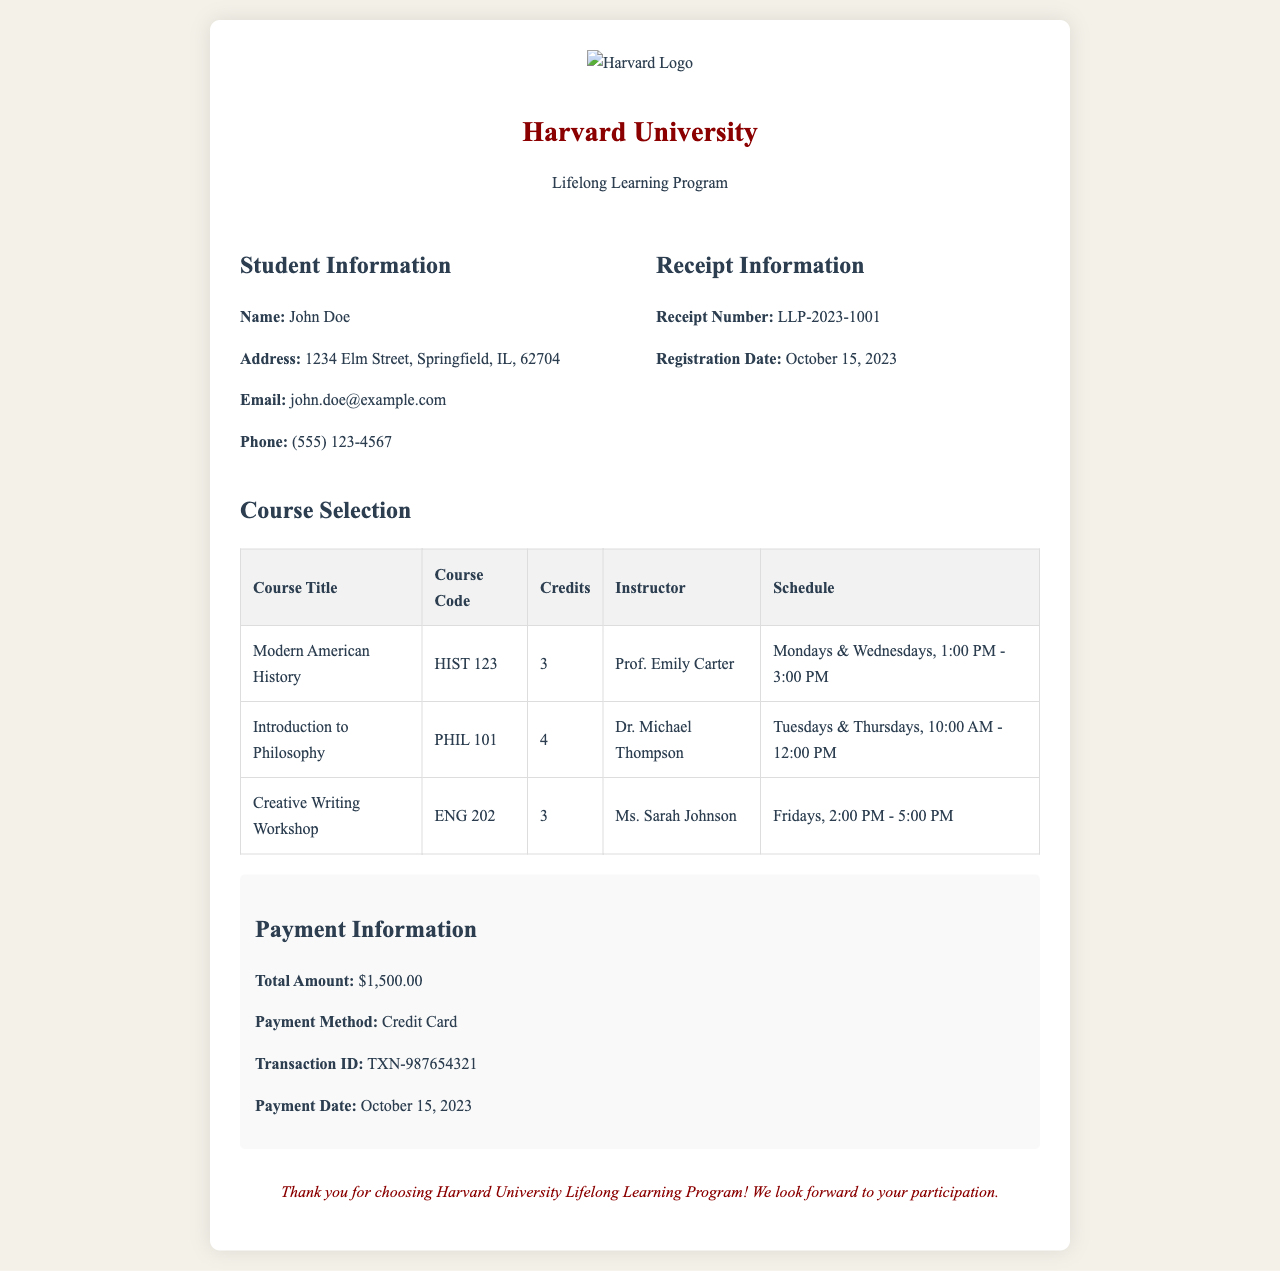What is the name of the student? The student’s name is mentioned in the student information section of the document.
Answer: John Doe What is the course code for "Introduction to Philosophy"? The course code is listed in the course selection table along with the course titles.
Answer: PHIL 101 What is the total amount charged for the lifelong learning program? The total amount is indicated clearly under the payment information section.
Answer: $1,500.00 Who is the instructor for "Creative Writing Workshop"? The instructor’s name is provided in the course selection table for that specific course.
Answer: Ms. Sarah Johnson On what date was the payment processed? The payment date can be found in the payment information section of the document.
Answer: October 15, 2023 How many credits does "Modern American History" offer? The number of credits for this course is specified in the course selection table.
Answer: 3 What is the receipt number? The receipt number is typically provided in the receipt information section for identification purposes.
Answer: LLP-2023-1001 Which days does "Introduction to Philosophy" meet? The schedule for the course shows the days it is held.
Answer: Tuesdays & Thursdays What type of payment was used for the registration fee? The payment method indicates how the registration fee was paid in the payment information section.
Answer: Credit Card 